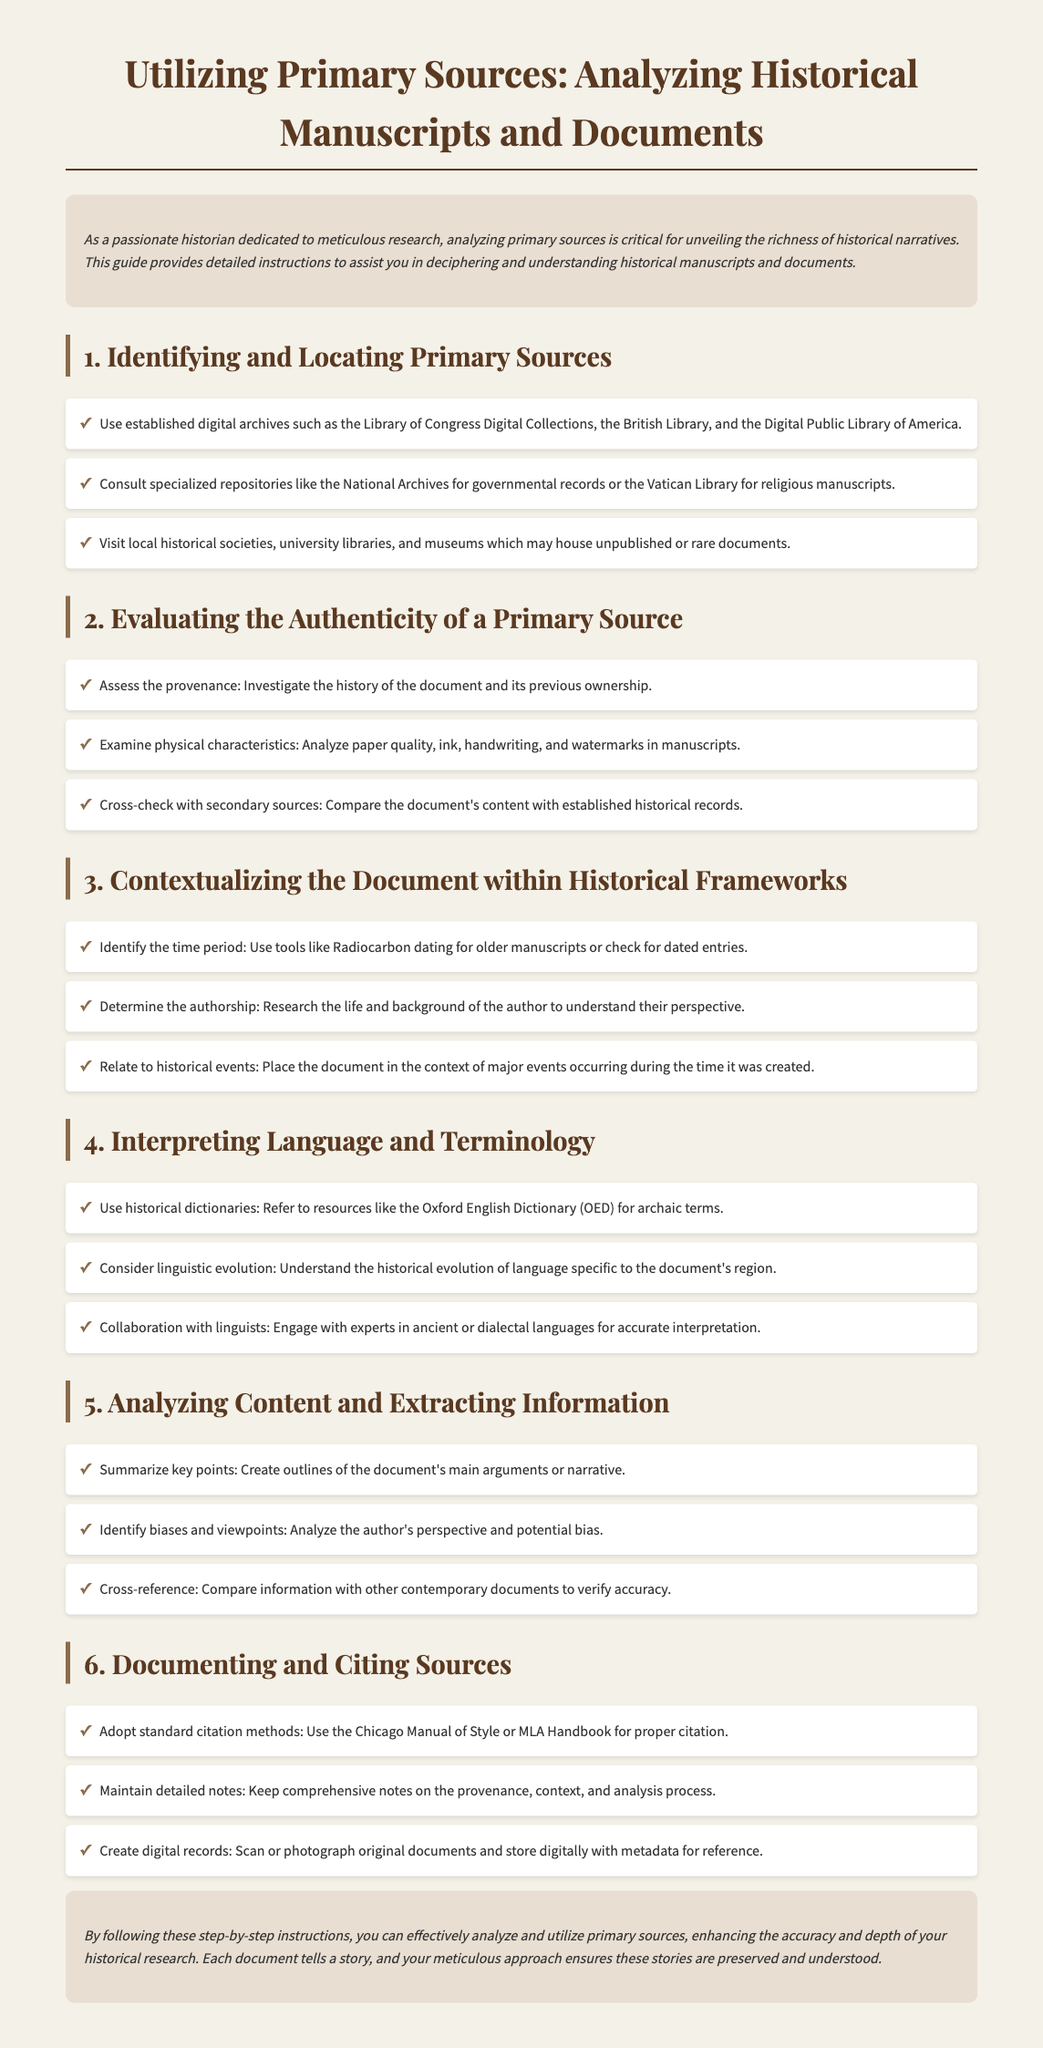what are the established digital archives mentioned? The document lists several established digital archives such as the Library of Congress Digital Collections, the British Library, and the Digital Public Library of America.
Answer: Library of Congress Digital Collections, British Library, Digital Public Library of America what is one method to evaluate the authenticity of a primary source? One method to evaluate authenticity is to assess the provenance by investigating the history of the document and its previous ownership.
Answer: Assess the provenance how can you contextualize a document in historical frameworks? You can contextualize a document by identifying the time period using tools like Radiocarbon dating or checking for dated entries.
Answer: Identify the time period which dictionary is recommended for interpreting archaic terms? The document recommends using the Oxford English Dictionary (OED) for interpreting archaic terms.
Answer: Oxford English Dictionary what citation method should be adopted according to the guide? The guide suggests adopting standard citation methods such as the Chicago Manual of Style or MLA Handbook for proper citation.
Answer: Chicago Manual of Style or MLA Handbook how many steps are outlined in the guide for analyzing historical manuscripts? The guide outlines six steps for analyzing historical manuscripts and documents.
Answer: Six steps which aspect of a primary source should be cross-checked with secondary sources? The content of the document should be cross-checked with secondary sources for authenticity and accuracy.
Answer: Content what is a strategy for analyzing content and extracting information? One strategy is to summarize key points by creating outlines of the document's main arguments or narrative.
Answer: Summarize key points 